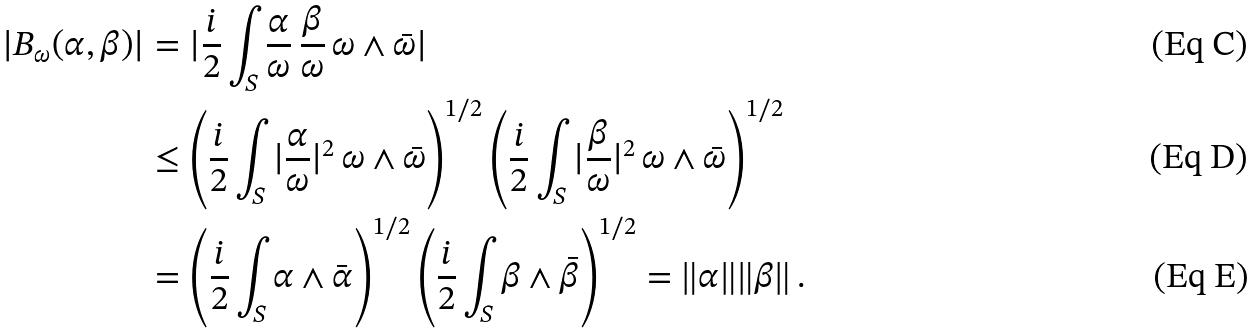<formula> <loc_0><loc_0><loc_500><loc_500>| B _ { \omega } ( \alpha , \beta ) | & = | \frac { i } { 2 } \int _ { S } \frac { \alpha } { \omega } \, \frac { \beta } { \omega } \, \omega \wedge \bar { \omega } | \\ & \leq \left ( \frac { i } { 2 } \int _ { S } | \frac { \alpha } { \omega } | ^ { 2 } \, \omega \wedge \bar { \omega } \right ) ^ { 1 / 2 } \left ( \frac { i } { 2 } \int _ { S } | \frac { \beta } { \omega } | ^ { 2 } \, \omega \wedge \bar { \omega } \right ) ^ { 1 / 2 } \\ & = \left ( \frac { i } { 2 } \int _ { S } \alpha \wedge \bar { \alpha } \right ) ^ { 1 / 2 } \left ( \frac { i } { 2 } \int _ { S } \beta \wedge \bar { \beta } \right ) ^ { 1 / 2 } = \| \alpha \| \| \beta \| \, .</formula> 